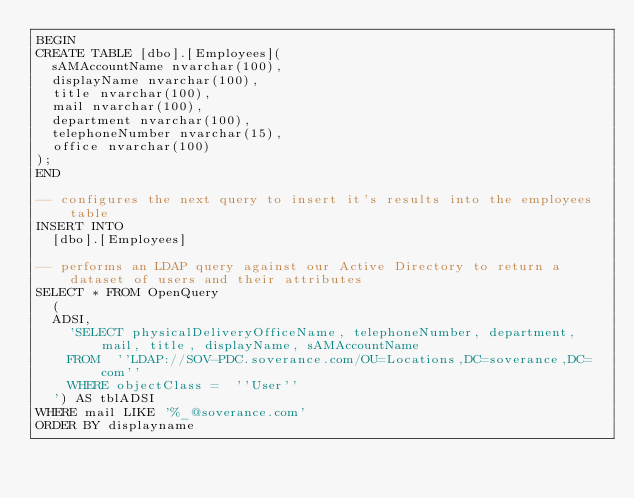<code> <loc_0><loc_0><loc_500><loc_500><_SQL_>BEGIN
CREATE TABLE [dbo].[Employees](
	sAMAccountName nvarchar(100),
	displayName nvarchar(100),
	title nvarchar(100),
	mail nvarchar(100),
	department nvarchar(100),
	telephoneNumber nvarchar(15),
	office nvarchar(100)
);
END

-- configures the next query to insert it's results into the employees table
INSERT INTO
	[dbo].[Employees]

-- performs an LDAP query against our Active Directory to return a dataset of users and their attributes
SELECT * FROM OpenQuery
  (
	ADSI,
		'SELECT physicalDeliveryOfficeName, telephoneNumber, department, mail, title, displayName, sAMAccountName
		FROM  ''LDAP://SOV-PDC.soverance.com/OU=Locations,DC=soverance,DC=com''
		WHERE objectClass =  ''User''
  ') AS tblADSI
WHERE mail LIKE '%_@soverance.com'
ORDER BY displayname</code> 